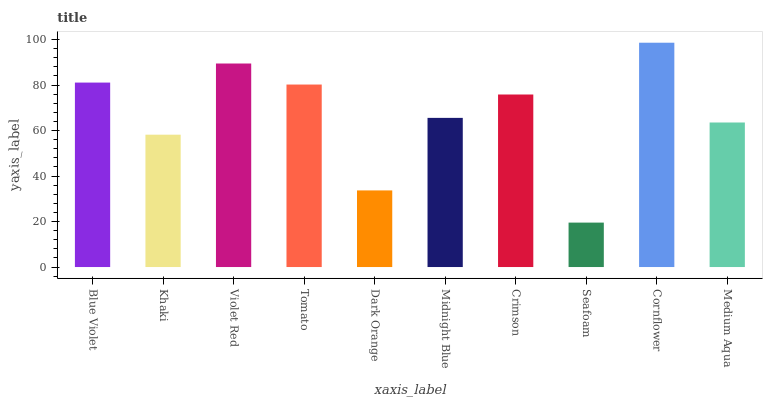Is Seafoam the minimum?
Answer yes or no. Yes. Is Cornflower the maximum?
Answer yes or no. Yes. Is Khaki the minimum?
Answer yes or no. No. Is Khaki the maximum?
Answer yes or no. No. Is Blue Violet greater than Khaki?
Answer yes or no. Yes. Is Khaki less than Blue Violet?
Answer yes or no. Yes. Is Khaki greater than Blue Violet?
Answer yes or no. No. Is Blue Violet less than Khaki?
Answer yes or no. No. Is Crimson the high median?
Answer yes or no. Yes. Is Midnight Blue the low median?
Answer yes or no. Yes. Is Midnight Blue the high median?
Answer yes or no. No. Is Blue Violet the low median?
Answer yes or no. No. 